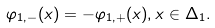Convert formula to latex. <formula><loc_0><loc_0><loc_500><loc_500>\varphi _ { 1 , - } ( x ) = - \varphi _ { 1 , + } ( x ) , x \in \Delta _ { 1 } .</formula> 